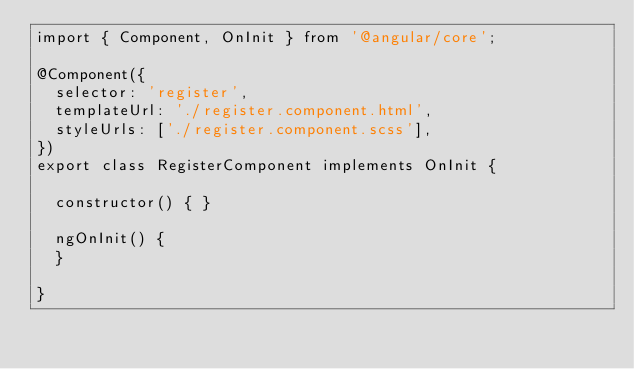<code> <loc_0><loc_0><loc_500><loc_500><_TypeScript_>import { Component, OnInit } from '@angular/core';

@Component({
  selector: 'register',
  templateUrl: './register.component.html',
  styleUrls: ['./register.component.scss'],
})
export class RegisterComponent implements OnInit {

  constructor() { }

  ngOnInit() {
  }

}
</code> 